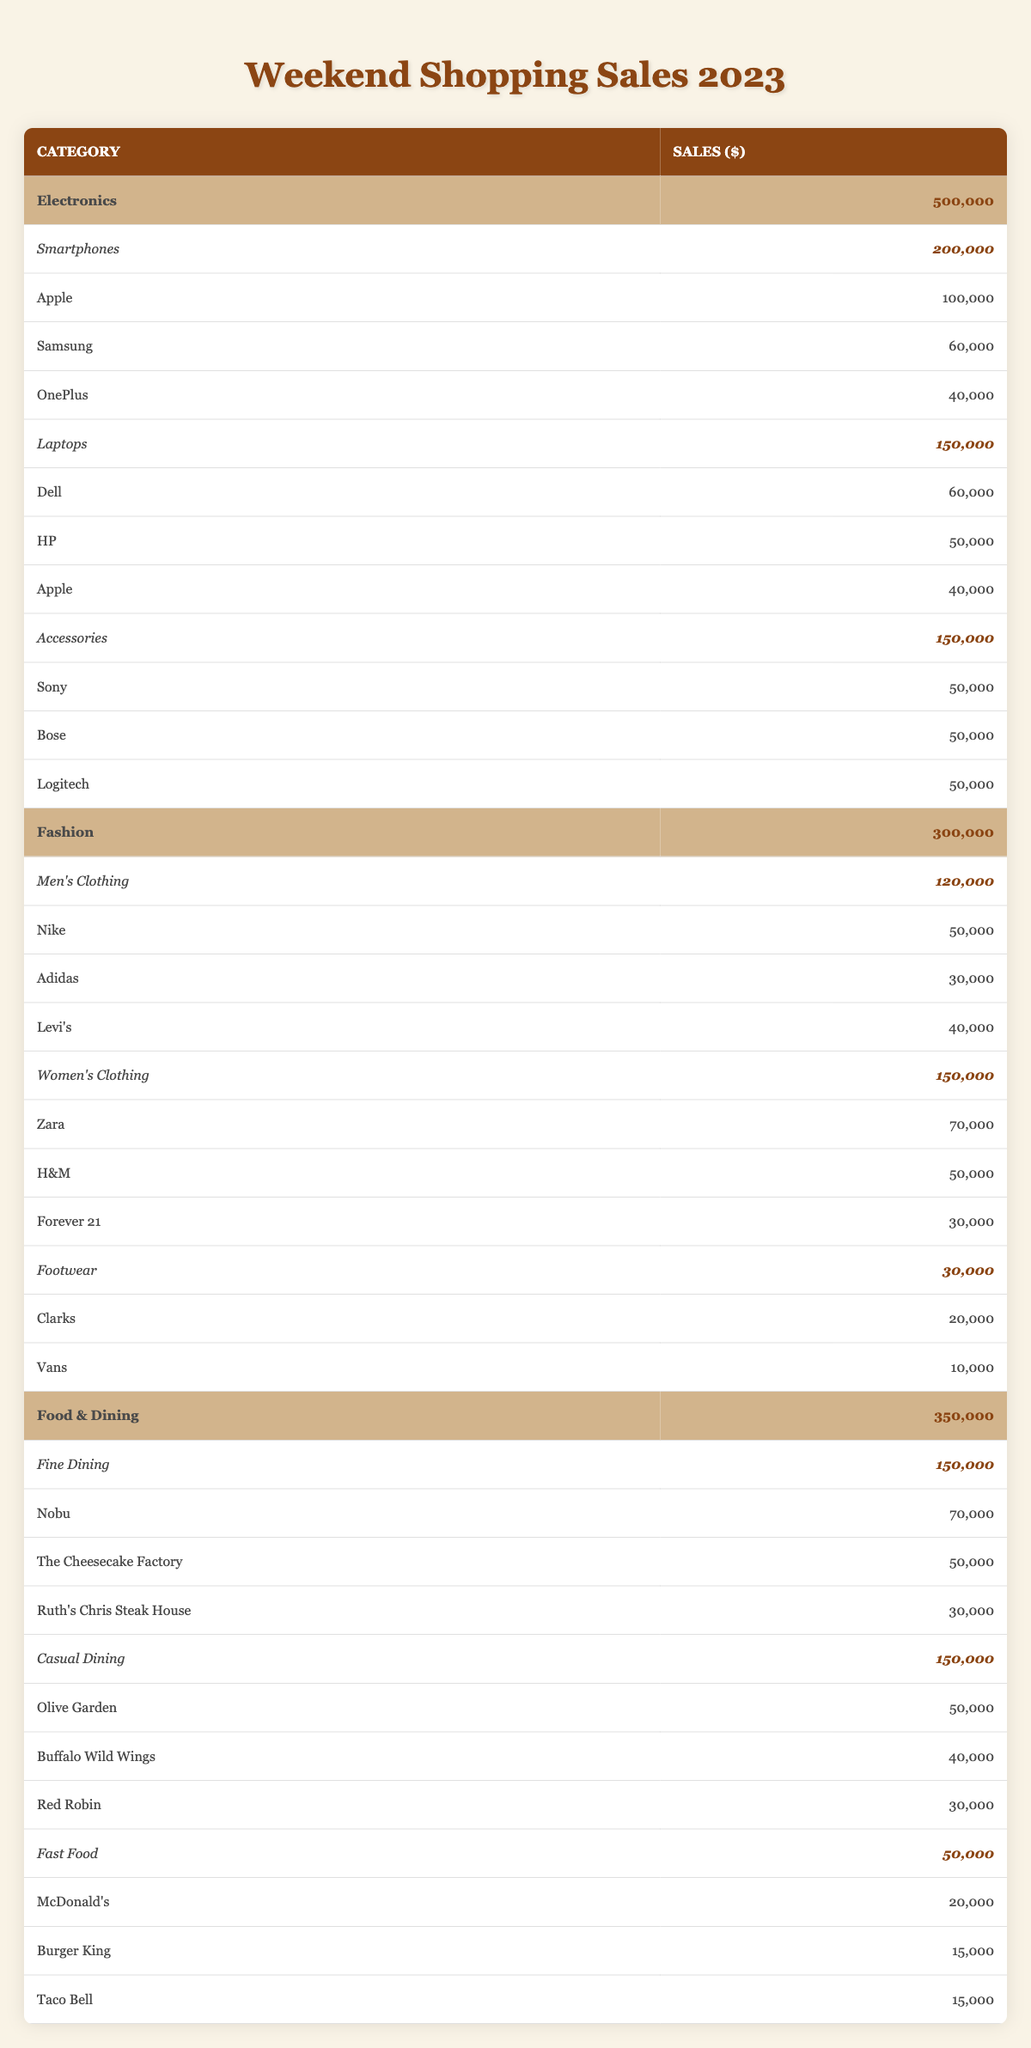What was the total sales in the Electronics category? The table shows the total sales for Electronics as 500,000. This value is clearly stated in the category row for Electronics.
Answer: 500,000 Which Fashion category had the highest sales? The table lists Men's Clothing with total sales of 120,000, Women's Clothing with 150,000, and Footwear with 30,000. The highest value is for Women's Clothing.
Answer: Women's Clothing What are the total sales for Fine Dining? The Fine Dining category has total sales reported as 150,000. This value can be directly found under the Fine Dining category in the table.
Answer: 150,000 True or False: Casual Dining had higher sales than Fast Food. The table shows Casual Dining sales at 150,000 and Fast Food at 50,000. Since 150,000 is greater than 50,000, the statement is true.
Answer: True What is the combined total sales of Food & Dining and Electronics? Food & Dining sales are 350,000 and Electronics sales are 500,000. Adding these together gives 350,000 + 500,000 = 850,000.
Answer: 850,000 What are the top three accessory brands by sales, and how much did they collectively earn? The table shows three accessory brands: Sony, Bose, and Logitech, each with sales of 50,000. Collectively, they earned 50,000 + 50,000 + 50,000 = 150,000.
Answer: 150,000 Which smartphone brand had the lowest sales, and what was its value? The sales for smartphones brand show Apple at 100,000, Samsung at 60,000, and OnePlus at 40,000. Among these, OnePlus has the lowest sales at 40,000.
Answer: OnePlus, 40,000 How much more did Women's Clothing sell than Men's Clothing? Women's Clothing sold 150,000 while Men's Clothing sold 120,000. The difference is 150,000 - 120,000 = 30,000, indicating Women's Clothing outperformed Men's.
Answer: 30,000 What percentage of the total Food & Dining sales comes from Fine Dining? Fine Dining sales are 150,000 and total Food & Dining sales are 350,000. To find the percentage, divide 150,000 by 350,000 and multiply by 100, which gives approximately 42.86%.
Answer: 42.86% 